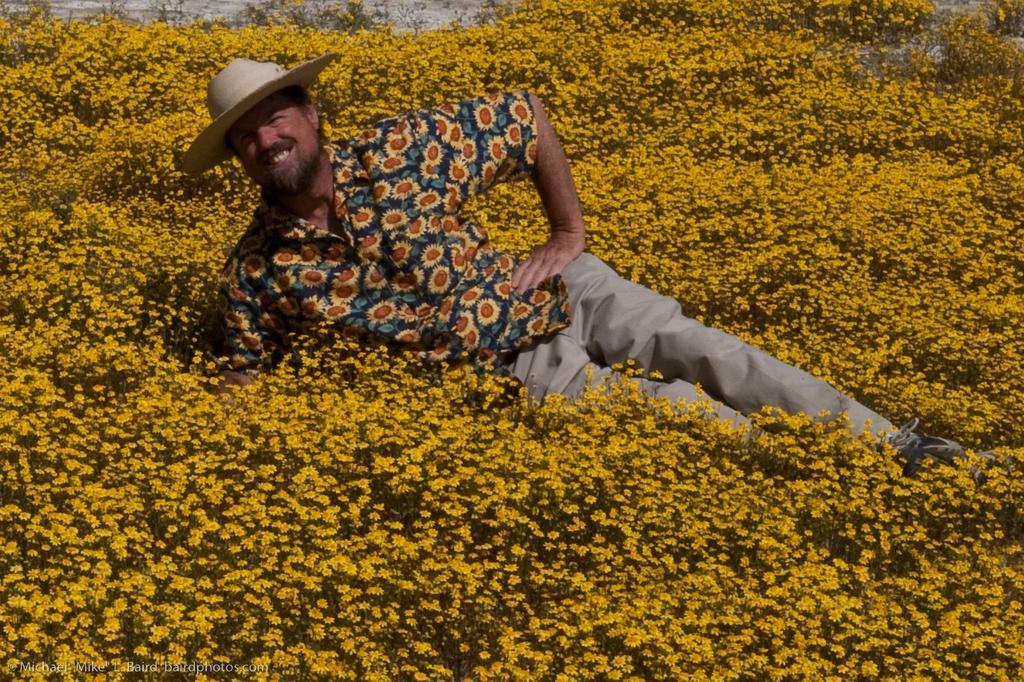How would you summarize this image in a sentence or two? In this image we can see a person wearing shirt and hat is lying on the flower garden. 